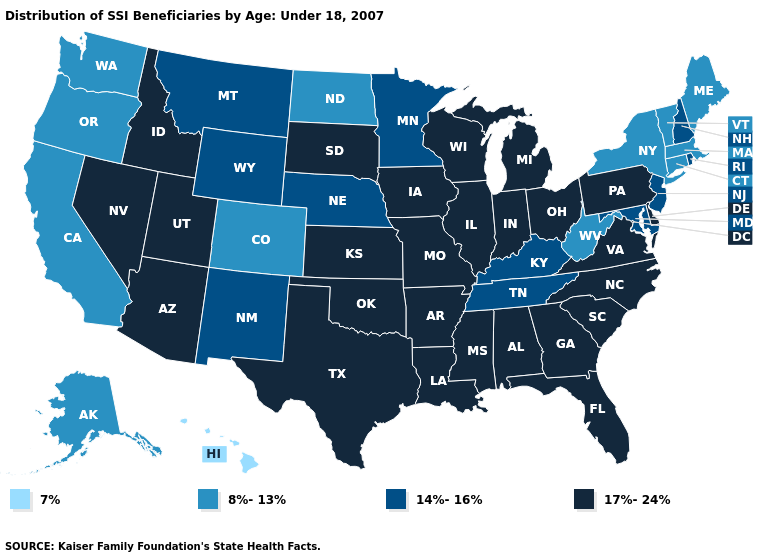What is the value of North Dakota?
Be succinct. 8%-13%. What is the value of New Hampshire?
Give a very brief answer. 14%-16%. What is the highest value in states that border New Hampshire?
Write a very short answer. 8%-13%. Name the states that have a value in the range 14%-16%?
Write a very short answer. Kentucky, Maryland, Minnesota, Montana, Nebraska, New Hampshire, New Jersey, New Mexico, Rhode Island, Tennessee, Wyoming. Among the states that border Ohio , which have the lowest value?
Quick response, please. West Virginia. Name the states that have a value in the range 8%-13%?
Short answer required. Alaska, California, Colorado, Connecticut, Maine, Massachusetts, New York, North Dakota, Oregon, Vermont, Washington, West Virginia. What is the value of Colorado?
Be succinct. 8%-13%. Does the first symbol in the legend represent the smallest category?
Answer briefly. Yes. What is the value of Missouri?
Answer briefly. 17%-24%. Does North Dakota have the lowest value in the MidWest?
Give a very brief answer. Yes. Among the states that border Missouri , does Illinois have the lowest value?
Concise answer only. No. Which states have the lowest value in the Northeast?
Answer briefly. Connecticut, Maine, Massachusetts, New York, Vermont. Which states have the highest value in the USA?
Write a very short answer. Alabama, Arizona, Arkansas, Delaware, Florida, Georgia, Idaho, Illinois, Indiana, Iowa, Kansas, Louisiana, Michigan, Mississippi, Missouri, Nevada, North Carolina, Ohio, Oklahoma, Pennsylvania, South Carolina, South Dakota, Texas, Utah, Virginia, Wisconsin. Does Colorado have the highest value in the West?
Answer briefly. No. 